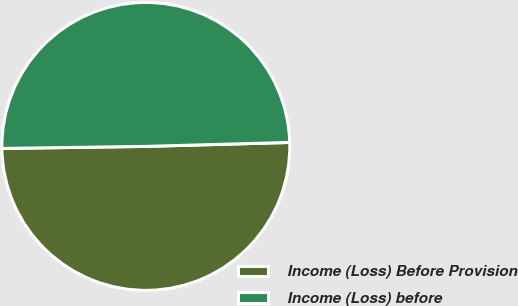<chart> <loc_0><loc_0><loc_500><loc_500><pie_chart><fcel>Income (Loss) Before Provision<fcel>Income (Loss) before<nl><fcel>50.21%<fcel>49.79%<nl></chart> 